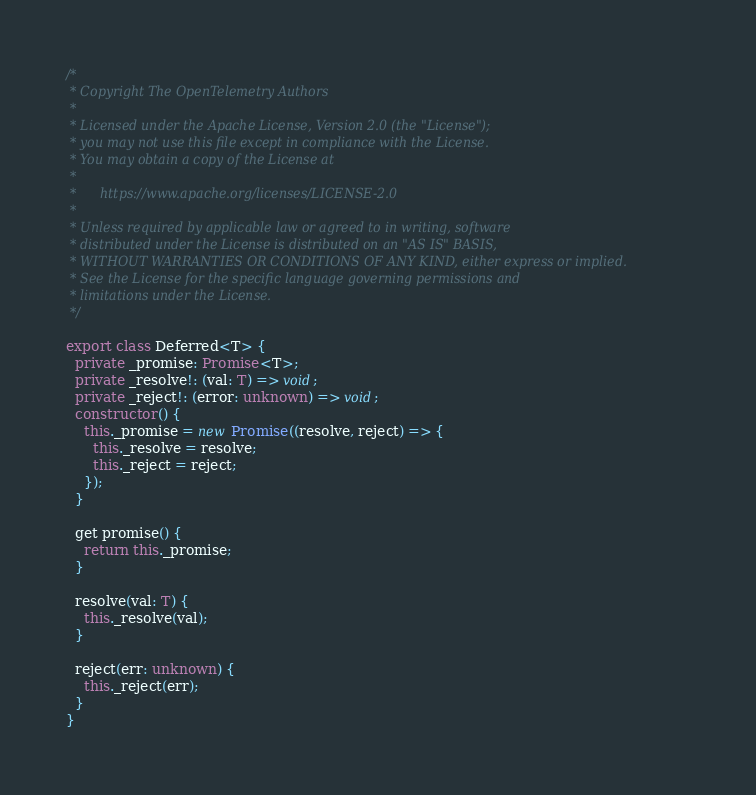Convert code to text. <code><loc_0><loc_0><loc_500><loc_500><_TypeScript_>/*
 * Copyright The OpenTelemetry Authors
 *
 * Licensed under the Apache License, Version 2.0 (the "License");
 * you may not use this file except in compliance with the License.
 * You may obtain a copy of the License at
 *
 *      https://www.apache.org/licenses/LICENSE-2.0
 *
 * Unless required by applicable law or agreed to in writing, software
 * distributed under the License is distributed on an "AS IS" BASIS,
 * WITHOUT WARRANTIES OR CONDITIONS OF ANY KIND, either express or implied.
 * See the License for the specific language governing permissions and
 * limitations under the License.
 */

export class Deferred<T> {
  private _promise: Promise<T>;
  private _resolve!: (val: T) => void;
  private _reject!: (error: unknown) => void;
  constructor() {
    this._promise = new Promise((resolve, reject) => {
      this._resolve = resolve;
      this._reject = reject;
    });
  }

  get promise() {
    return this._promise;
  }

  resolve(val: T) {
    this._resolve(val);
  }

  reject(err: unknown) {
    this._reject(err);
  }
}
</code> 